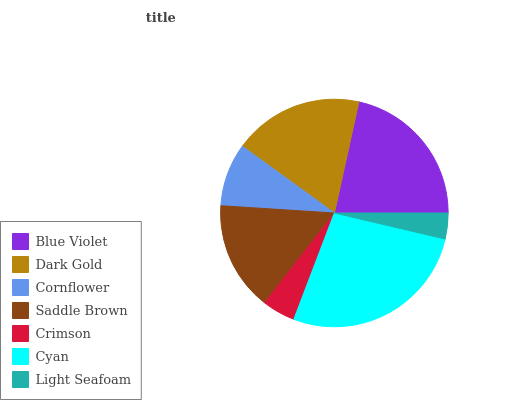Is Light Seafoam the minimum?
Answer yes or no. Yes. Is Cyan the maximum?
Answer yes or no. Yes. Is Dark Gold the minimum?
Answer yes or no. No. Is Dark Gold the maximum?
Answer yes or no. No. Is Blue Violet greater than Dark Gold?
Answer yes or no. Yes. Is Dark Gold less than Blue Violet?
Answer yes or no. Yes. Is Dark Gold greater than Blue Violet?
Answer yes or no. No. Is Blue Violet less than Dark Gold?
Answer yes or no. No. Is Saddle Brown the high median?
Answer yes or no. Yes. Is Saddle Brown the low median?
Answer yes or no. Yes. Is Dark Gold the high median?
Answer yes or no. No. Is Light Seafoam the low median?
Answer yes or no. No. 